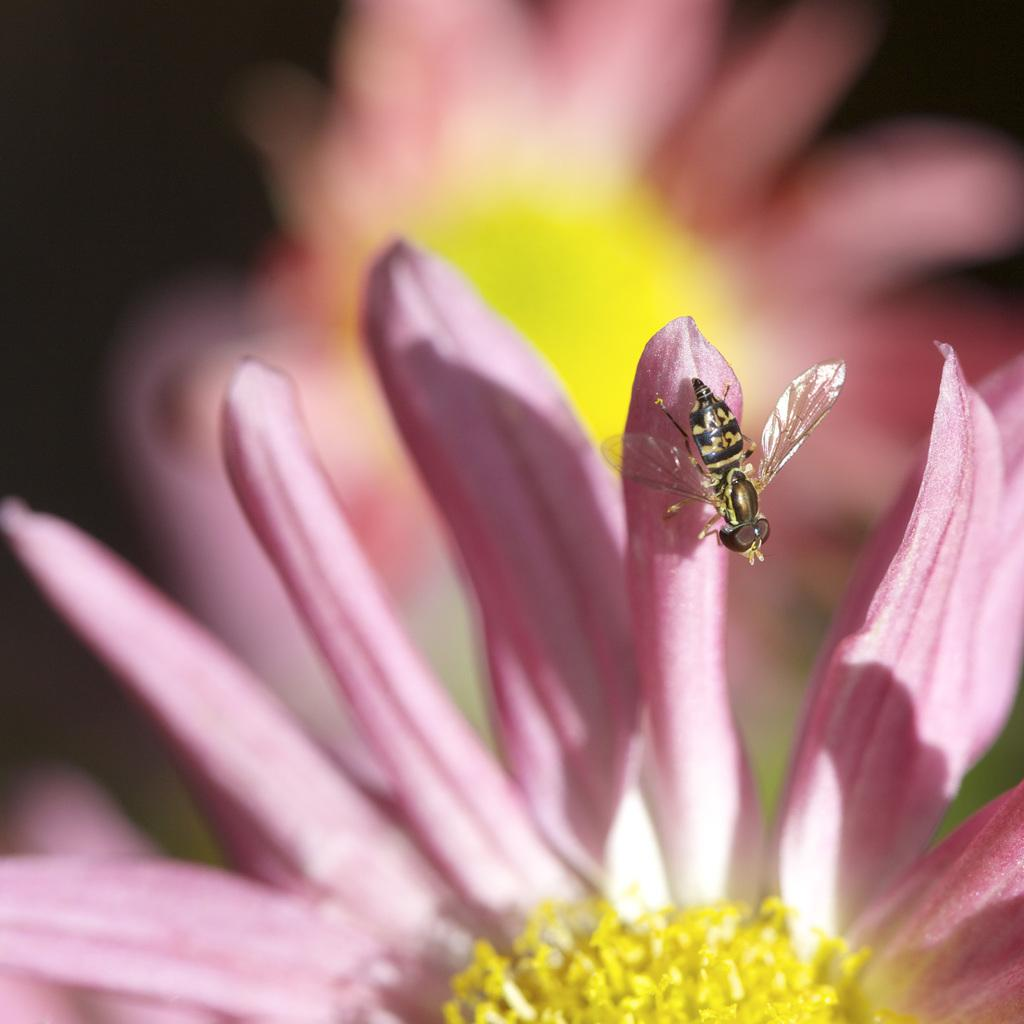What type of creature can be seen in the image? There is an insect in the image. What other elements are present in the image? There are flowers in the image. What type of flame can be seen in the image? There is no flame present in the image; it features an insect and flowers. Is the insect's grandmother visible in the image? There is no grandmother present in the image, as it only features an insect and flowers. 